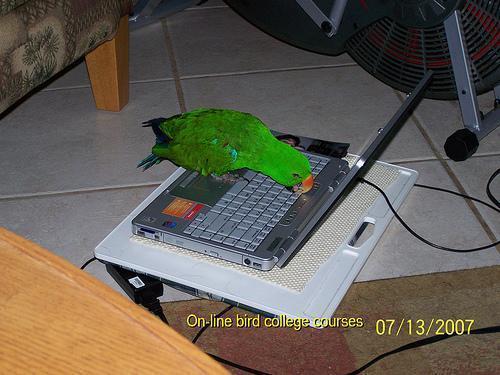How many birds?
Give a very brief answer. 1. 